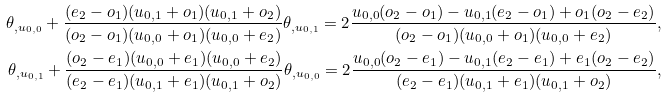Convert formula to latex. <formula><loc_0><loc_0><loc_500><loc_500>\theta _ { , u _ { 0 , 0 } } + \frac { ( e _ { 2 } - o _ { 1 } ) ( u _ { 0 , 1 } + o _ { 1 } ) ( u _ { 0 , 1 } + o _ { 2 } ) } { ( o _ { 2 } - o _ { 1 } ) ( u _ { 0 , 0 } + o _ { 1 } ) ( u _ { 0 , 0 } + e _ { 2 } ) } \theta _ { , u _ { 0 , 1 } } = 2 \frac { u _ { 0 , 0 } ( o _ { 2 } - o _ { 1 } ) - u _ { 0 , 1 } ( e _ { 2 } - o _ { 1 } ) + o _ { 1 } ( o _ { 2 } - e _ { 2 } ) } { ( o _ { 2 } - o _ { 1 } ) ( u _ { 0 , 0 } + o _ { 1 } ) ( u _ { 0 , 0 } + e _ { 2 } ) } , \\ \theta _ { , u _ { 0 , 1 } } + \frac { ( o _ { 2 } - e _ { 1 } ) ( u _ { 0 , 0 } + e _ { 1 } ) ( u _ { 0 , 0 } + e _ { 2 } ) } { ( e _ { 2 } - e _ { 1 } ) ( u _ { 0 , 1 } + e _ { 1 } ) ( u _ { 0 , 1 } + o _ { 2 } ) } \theta _ { , u _ { 0 , 0 } } = 2 \frac { u _ { 0 , 0 } ( o _ { 2 } - e _ { 1 } ) - u _ { 0 , 1 } ( e _ { 2 } - e _ { 1 } ) + e _ { 1 } ( o _ { 2 } - e _ { 2 } ) } { ( e _ { 2 } - e _ { 1 } ) ( u _ { 0 , 1 } + e _ { 1 } ) ( u _ { 0 , 1 } + o _ { 2 } ) } ,</formula> 